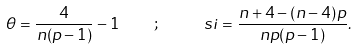Convert formula to latex. <formula><loc_0><loc_0><loc_500><loc_500>\theta = \frac { 4 } { n ( p - 1 ) } - 1 \quad ; \quad \ s i = \frac { n + 4 - ( n - 4 ) p } { n p ( p - 1 ) } .</formula> 